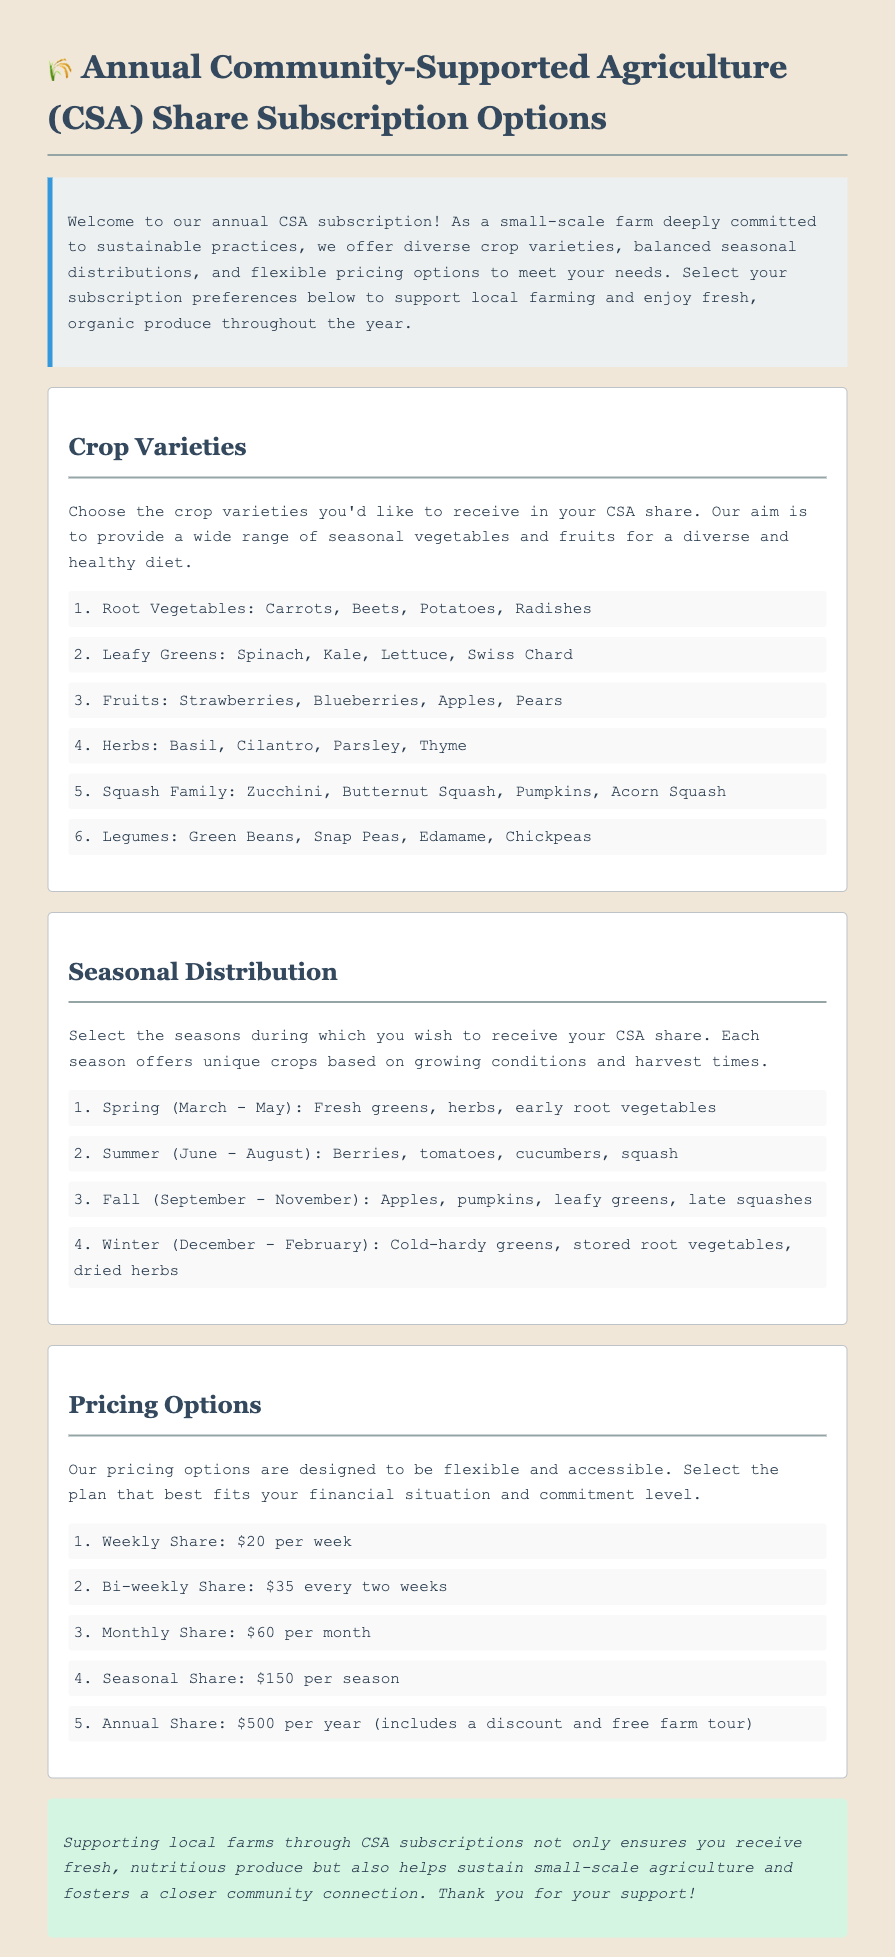What are the available crop varieties? The crop varieties listed in the document include root vegetables, leafy greens, fruits, herbs, squash family, and legumes.
Answer: Root Vegetables, Leafy Greens, Fruits, Herbs, Squash Family, Legumes What is the price of a weekly share? The weekly share cost is mentioned under pricing options, indicating it is $20 per week.
Answer: $20 per week Which season includes apples in the CSA share? The seasons are described, and apples are mentioned to be available in the fall season.
Answer: Fall How much does an annual share cost? The document specifies that an annual share costs $500, which is also noted to include a discount and a free farm tour.
Answer: $500 What type of greens are available in winter? The document specifies cold-hardy greens being part of the winter CSA share.
Answer: Cold-hardy greens How are the pricing options structured? The document outlines that pricing options are designed to be flexible and accessible, covering various plans.
Answer: Flexible and accessible Which month does the spring season start? The seasonal distribution section indicates that spring starts in March.
Answer: March What are the vegetable options available in summer? The summer CSA share includes berries, tomatoes, cucumbers, and squash, as stated in the seasonal distribution section.
Answer: Berries, tomatoes, cucumbers, squash What are the benefits of supporting local farms through CSA? The additional info section emphasizes receiving fresh produce and sustaining small-scale agriculture as key benefits.
Answer: Fresh produce, sustaining small-scale agriculture 